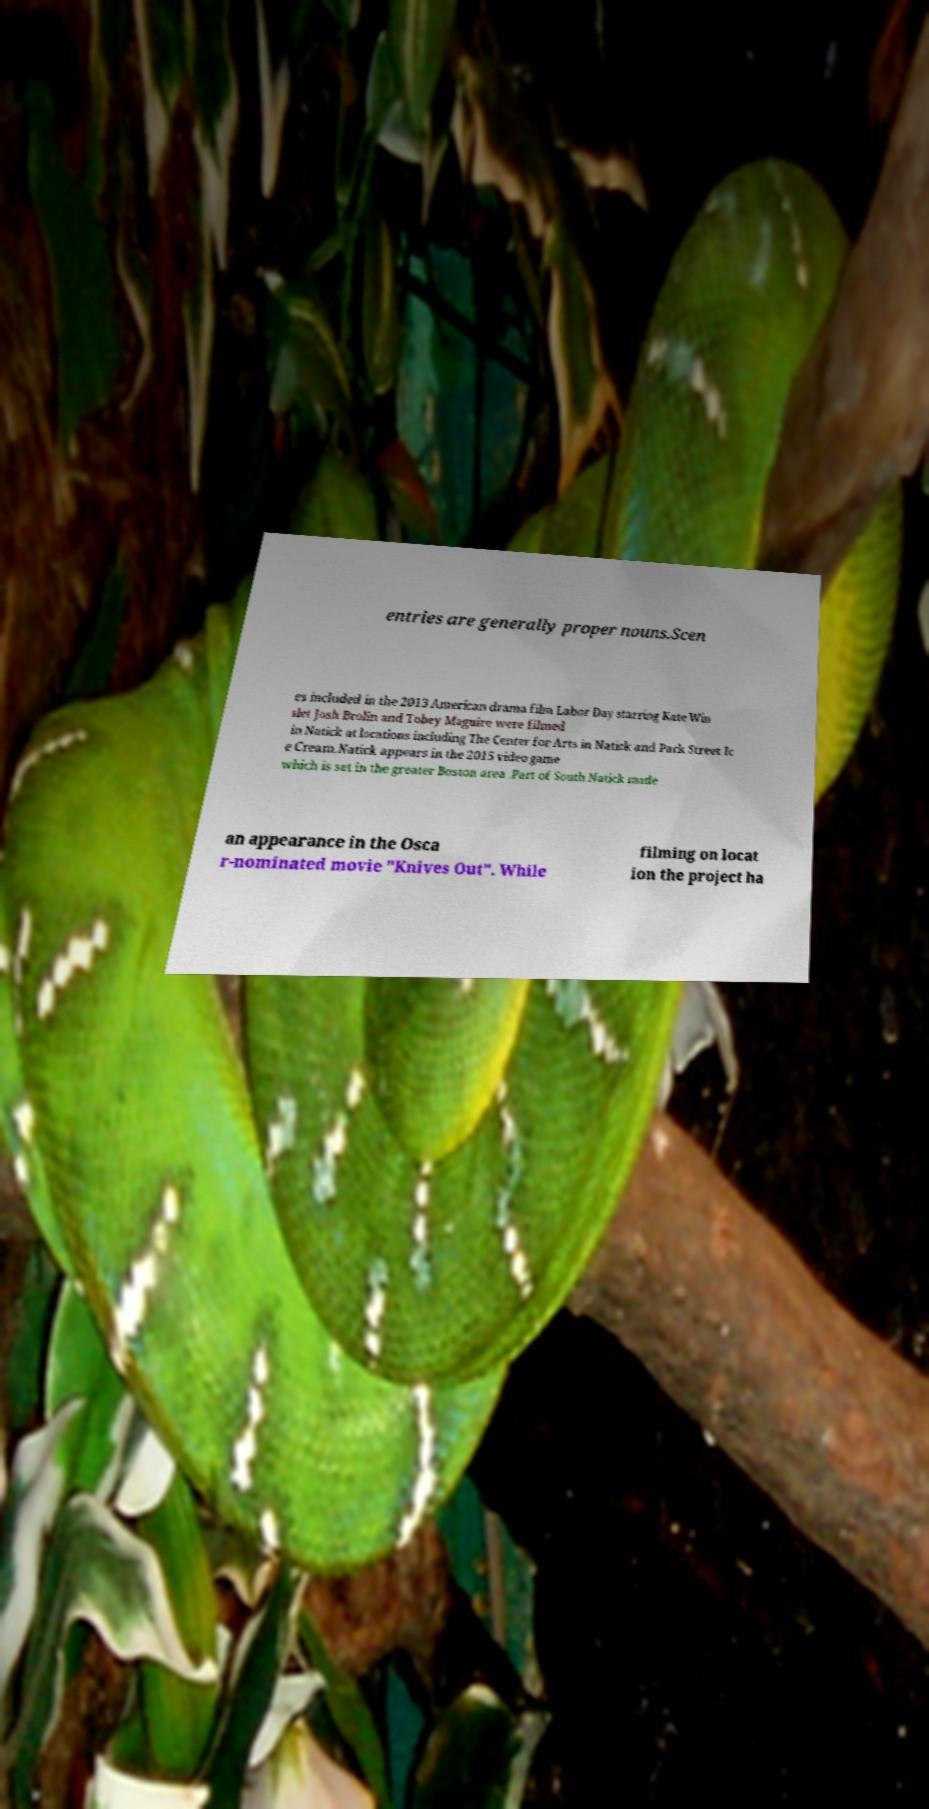Can you accurately transcribe the text from the provided image for me? entries are generally proper nouns.Scen es included in the 2013 American drama film Labor Day starring Kate Win slet Josh Brolin and Tobey Maguire were filmed in Natick at locations including The Center for Arts in Natick and Park Street Ic e Cream.Natick appears in the 2015 video game which is set in the greater Boston area .Part of South Natick made an appearance in the Osca r-nominated movie "Knives Out". While filming on locat ion the project ha 